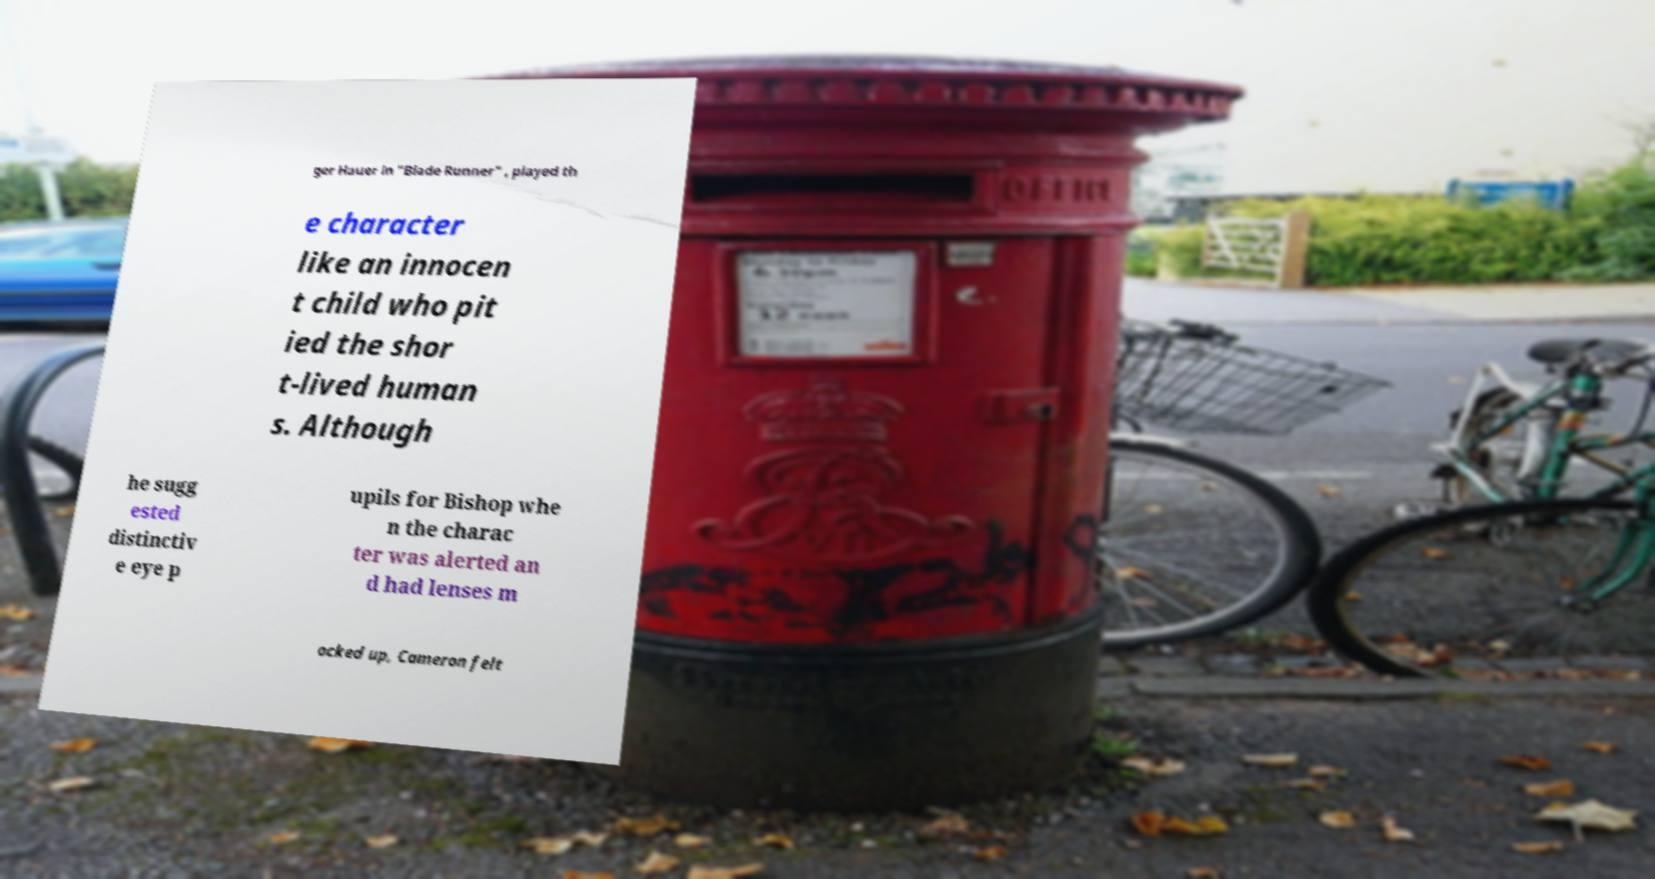Can you read and provide the text displayed in the image?This photo seems to have some interesting text. Can you extract and type it out for me? ger Hauer in "Blade Runner" , played th e character like an innocen t child who pit ied the shor t-lived human s. Although he sugg ested distinctiv e eye p upils for Bishop whe n the charac ter was alerted an d had lenses m ocked up, Cameron felt 